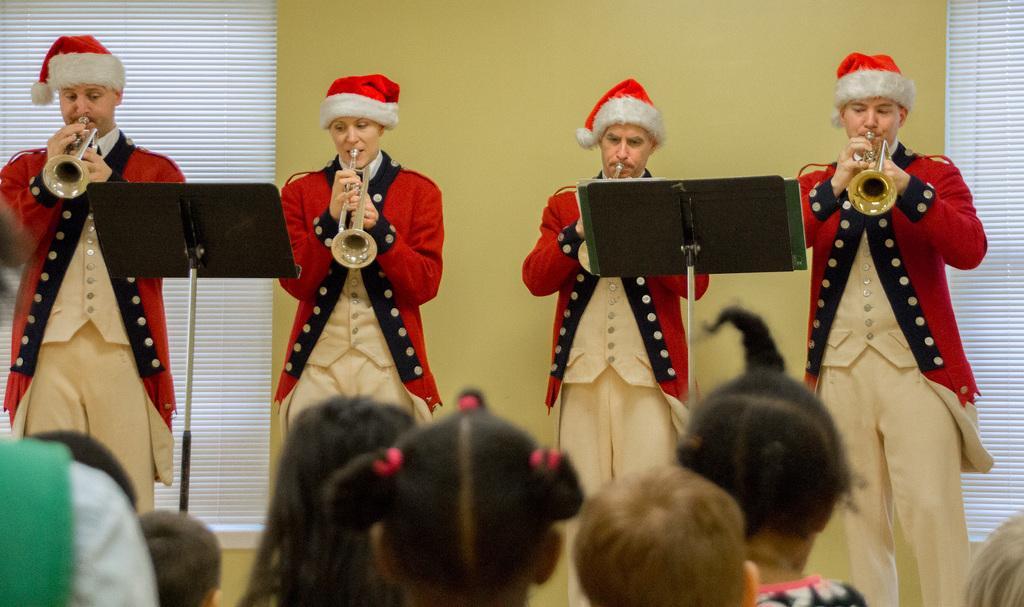Could you give a brief overview of what you see in this image? In this image we can see the people standing and few people playing musical instruments. And we can see the stands. In the background, we can see the wall and window shades. 